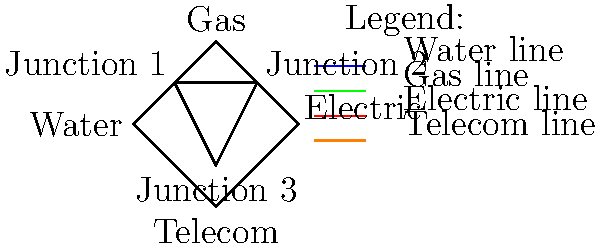In the diagram representing the city's underground utility network, how many closed loops are formed by the interconnections between different utility systems? To determine the number of closed loops in the underground utility network, we need to carefully analyze the diagram:

1. First, identify the main utility nodes:
   - Water (A)
   - Gas (B)
   - Electric (C)
   - Telecom (D)

2. Next, identify the junction nodes:
   - Junction 1 (E)
   - Junction 2 (F)
   - Junction 3 (G)

3. Now, let's count the closed loops:
   
   Loop 1: A - E - B - F - C - G - D
   This forms the outer perimeter of the network.
   
   Loop 2: E - F - G
   This forms the inner triangle connecting the three junctions.

4. Count the total number of closed loops:
   Total loops = 2

It's important to note that while there are more connections visible, we are only counting distinct closed loops. The connections between the main utility nodes and the junctions do not form additional closed loops beyond the two we've identified.

This topology demonstrates the interconnected nature of urban utility systems, highlighting the complexity and potential vulnerabilities in underground infrastructure.
Answer: 2 closed loops 